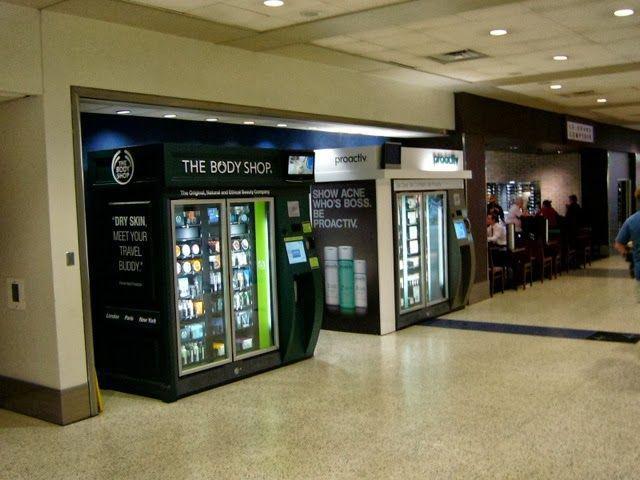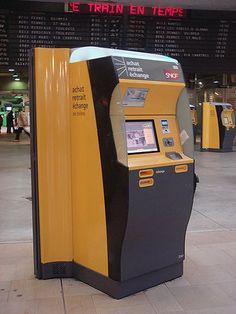The first image is the image on the left, the second image is the image on the right. Considering the images on both sides, is "There is a kiosk with people nearby." valid? Answer yes or no. Yes. 